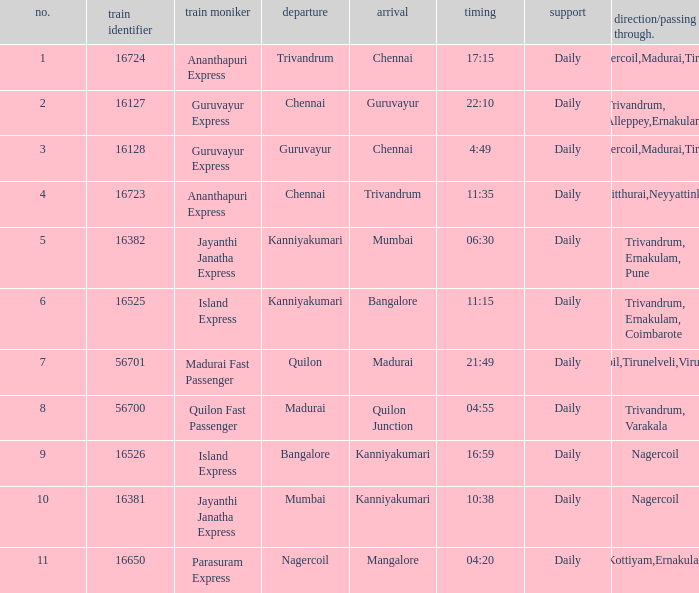What is the route/via when the destination is listed as Madurai? Nagercoil,Tirunelveli,Virudunagar. 